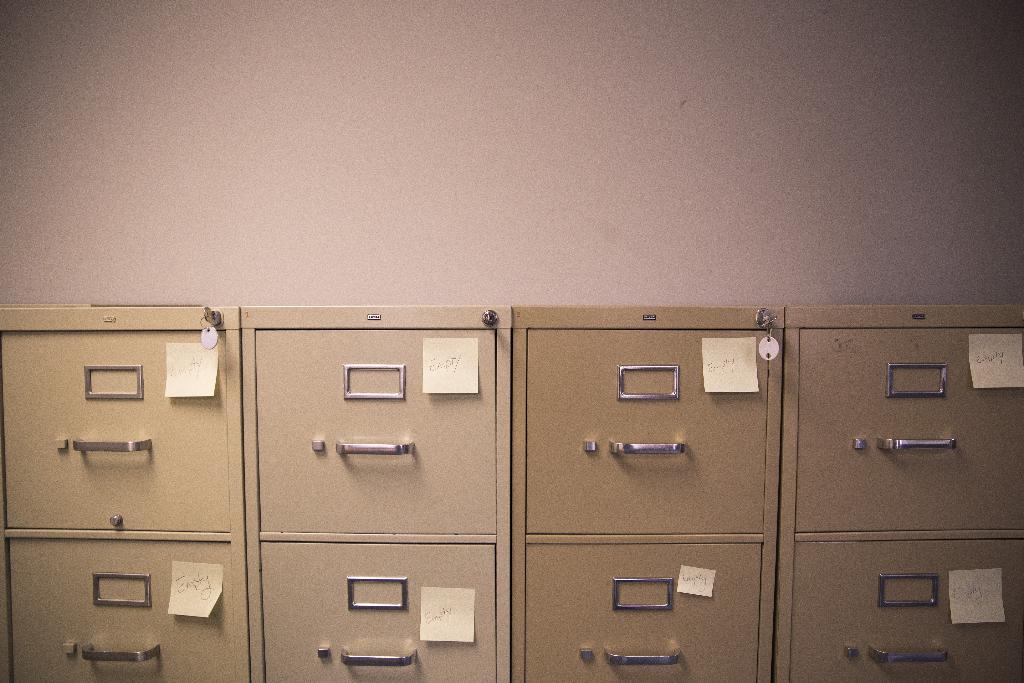How would you summarize this image in a sentence or two? In this image there are lockers and we can see sticky notes pasted on the lockers. In the background there is a wall. 